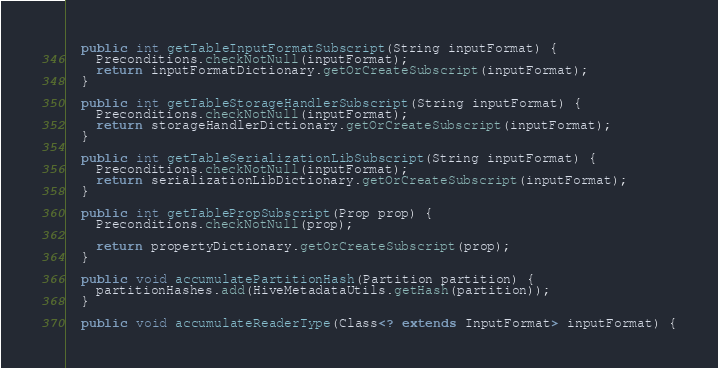<code> <loc_0><loc_0><loc_500><loc_500><_Java_>
  public int getTableInputFormatSubscript(String inputFormat) {
    Preconditions.checkNotNull(inputFormat);
    return inputFormatDictionary.getOrCreateSubscript(inputFormat);
  }

  public int getTableStorageHandlerSubscript(String inputFormat) {
    Preconditions.checkNotNull(inputFormat);
    return storageHandlerDictionary.getOrCreateSubscript(inputFormat);
  }

  public int getTableSerializationLibSubscript(String inputFormat) {
    Preconditions.checkNotNull(inputFormat);
    return serializationLibDictionary.getOrCreateSubscript(inputFormat);
  }

  public int getTablePropSubscript(Prop prop) {
    Preconditions.checkNotNull(prop);

    return propertyDictionary.getOrCreateSubscript(prop);
  }

  public void accumulatePartitionHash(Partition partition) {
    partitionHashes.add(HiveMetadataUtils.getHash(partition));
  }

  public void accumulateReaderType(Class<? extends InputFormat> inputFormat) {</code> 